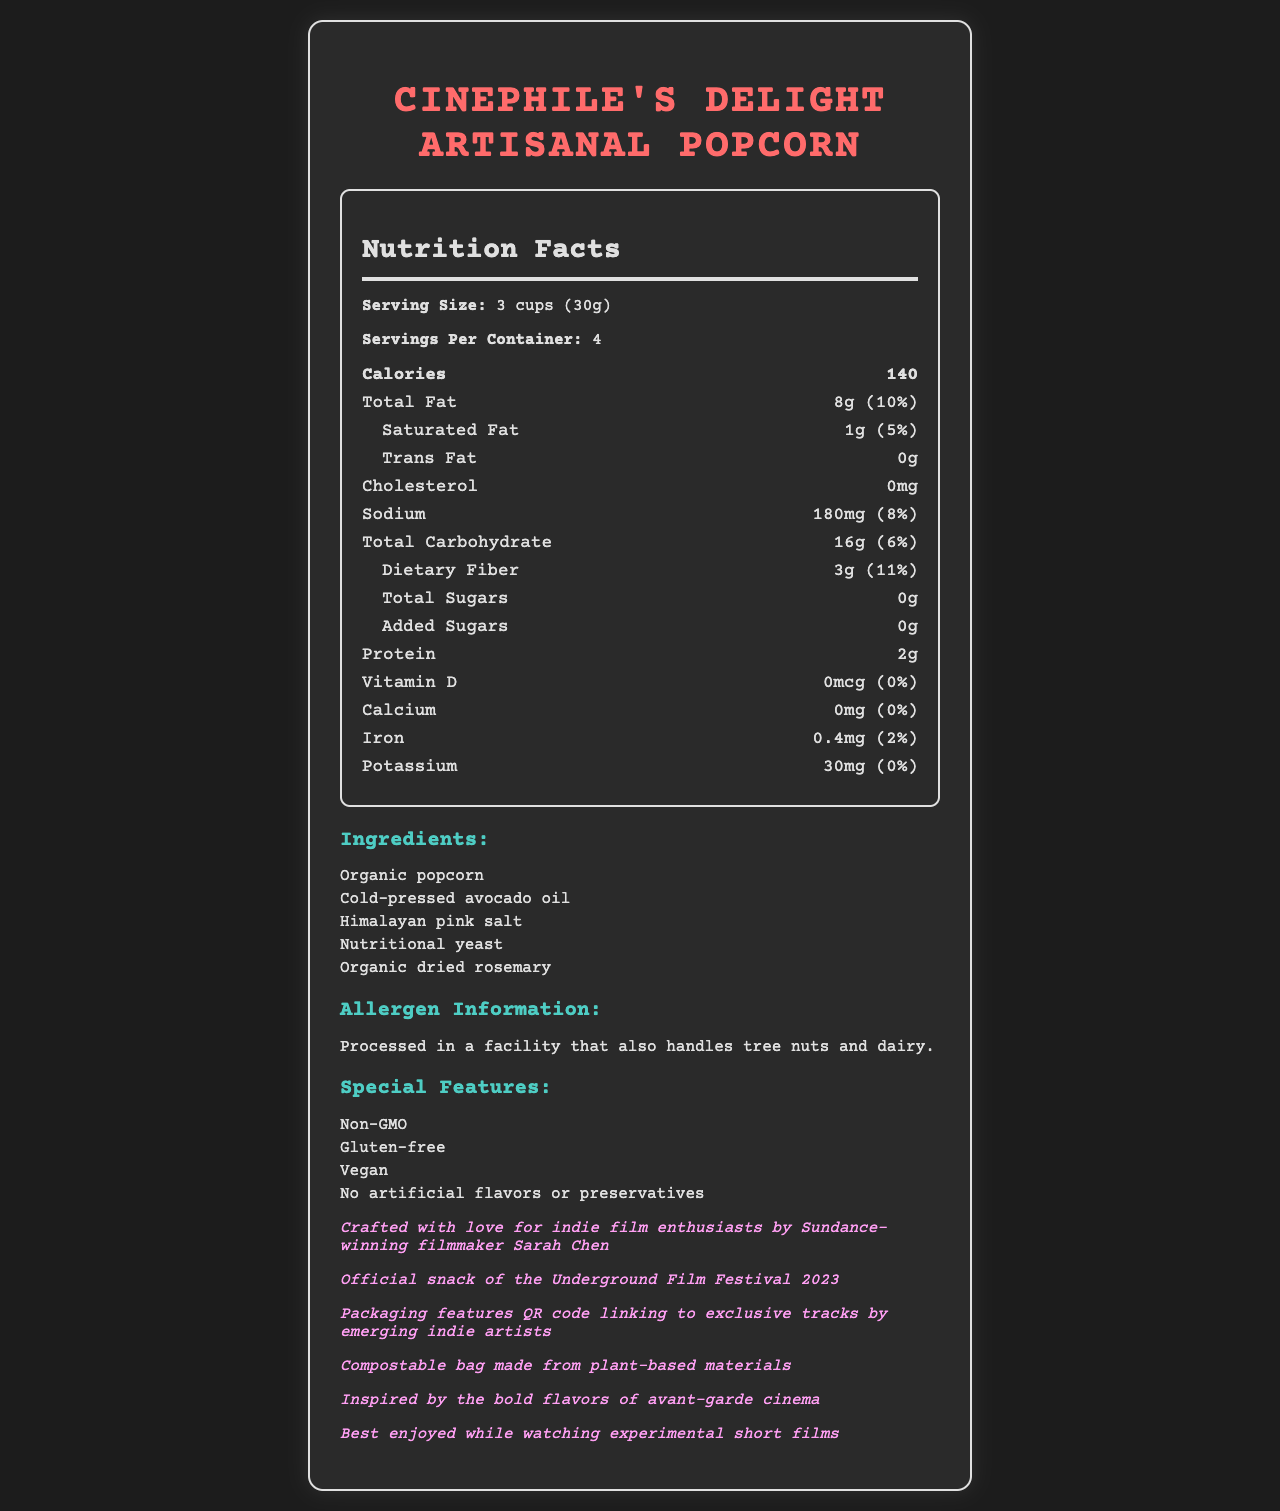what is the serving size for Cinephile's Delight Artisanal Popcorn? The serving size is clearly mentioned at the beginning of the Nutrition Facts section as "Serving Size: 3 cups (30g)."
Answer: 3 cups (30g) how many calories are in one serving? The calorie count per serving is visibly listed under the bold "Calories" heading in the Nutrition Facts section.
Answer: 140 what ingredients are used in this popcorn? The ingredients are listed under the "Ingredients" section.
Answer: Organic popcorn, Cold-pressed avocado oil, Himalayan pink salt, Nutritional yeast, Organic dried rosemary what allergen information is provided? The allergen information is stated explicitly under the "Allergen Information" section.
Answer: Processed in a facility that also handles tree nuts and dairy. what is the daily value percentage of total fat? The daily value percentage for total fat is listed next to the amount of total fat in the Nutrition Facts section.
Answer: 10% which of the following vitamins or minerals does this popcorn contain in the highest amount? A. Vitamin D B. Calcium C. Iron D. Potassium The Nutrition Facts section shows that iron content is 0.4mg (2% daily value), which is higher in percentage compared to Vitamin D, Calcium, and Potassium.
Answer: C. Iron how much sodium is in one serving? A. 140mg B. 180mg C. 200mg D. 220mg The amount of sodium per serving is listed as 180mg in the Nutrition Facts section.
Answer: B. 180mg is this popcorn non-GMO? In the "Special Features" section, it is indicated that the product is Non-GMO.
Answer: Yes what is the official snack of the Underground Film Festival 2023? This information is stated in the "Festival Exclusive" section.
Answer: Cinephile's Delight Artisanal Popcorn what special features does this popcorn have? The special features are listed in their own section in the document.
Answer: Non-GMO, Gluten-free, Vegan, No artificial flavors or preservatives does this popcorn contain any added sugars? The Nutrition Facts section shows that the amount of added sugars is 0g.
Answer: No is this popcorn suitable for vegans? The "Special Features" section confirms that the product is Vegan.
Answer: Yes summarize the main features of Cinephile's Delight Artisanal Popcorn The document outlines the product as a health-conscious, eco-friendly snack specially crafted for cinephiles, emphasizing its organic ingredients, nutritional benefits, and exclusive music collaborations.
Answer: This artisanal popcorn is branded for indie film enthusiasts and features exclusive tracks from emerging indie artists. It is Non-GMO, Gluten-free, Vegan, and free from artificial flavors or preservatives. The packaging is eco-friendly and compostable. The popcorn contains organic ingredients like popcorn, avocado oil, Himalayan pink salt, nutritional yeast, and dried rosemary. It's processed in a facility that handles tree nuts and dairy. The nutrition facts highlight low calories, a good amount of dietary fiber, and no cholesterol or trans fat. It's the official snack of the Underground Film Festival 2023. how much Vitamin C is in each serving? The Nutrition Facts section does not provide information about the Vitamin C content.
Answer: Not enough information 